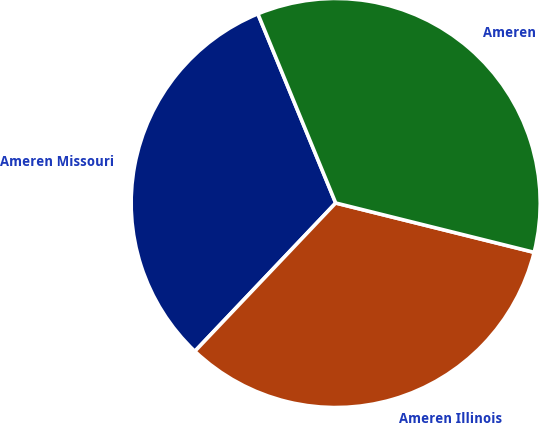Convert chart. <chart><loc_0><loc_0><loc_500><loc_500><pie_chart><fcel>Ameren Missouri<fcel>Ameren Illinois<fcel>Ameren<nl><fcel>31.7%<fcel>33.21%<fcel>35.09%<nl></chart> 